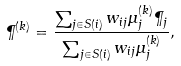Convert formula to latex. <formula><loc_0><loc_0><loc_500><loc_500>\P ^ { ( k ) } = \frac { \sum _ { j \in S ( i ) } w _ { i j } \mu ^ { ( k ) } _ { j } \P _ { j } } { \sum _ { j \in S ( i ) } w _ { i j } \mu ^ { ( k ) } _ { j } } ,</formula> 